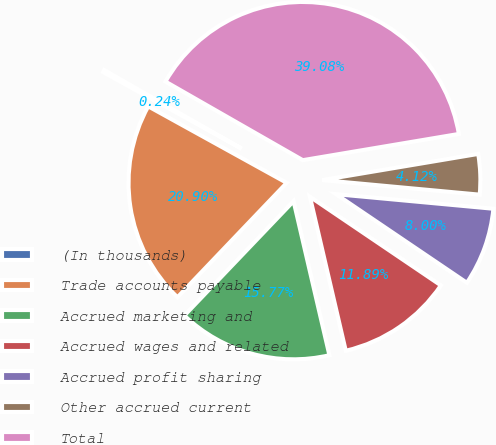Convert chart to OTSL. <chart><loc_0><loc_0><loc_500><loc_500><pie_chart><fcel>(In thousands)<fcel>Trade accounts payable<fcel>Accrued marketing and<fcel>Accrued wages and related<fcel>Accrued profit sharing<fcel>Other accrued current<fcel>Total<nl><fcel>0.24%<fcel>20.9%<fcel>15.77%<fcel>11.89%<fcel>8.0%<fcel>4.12%<fcel>39.08%<nl></chart> 